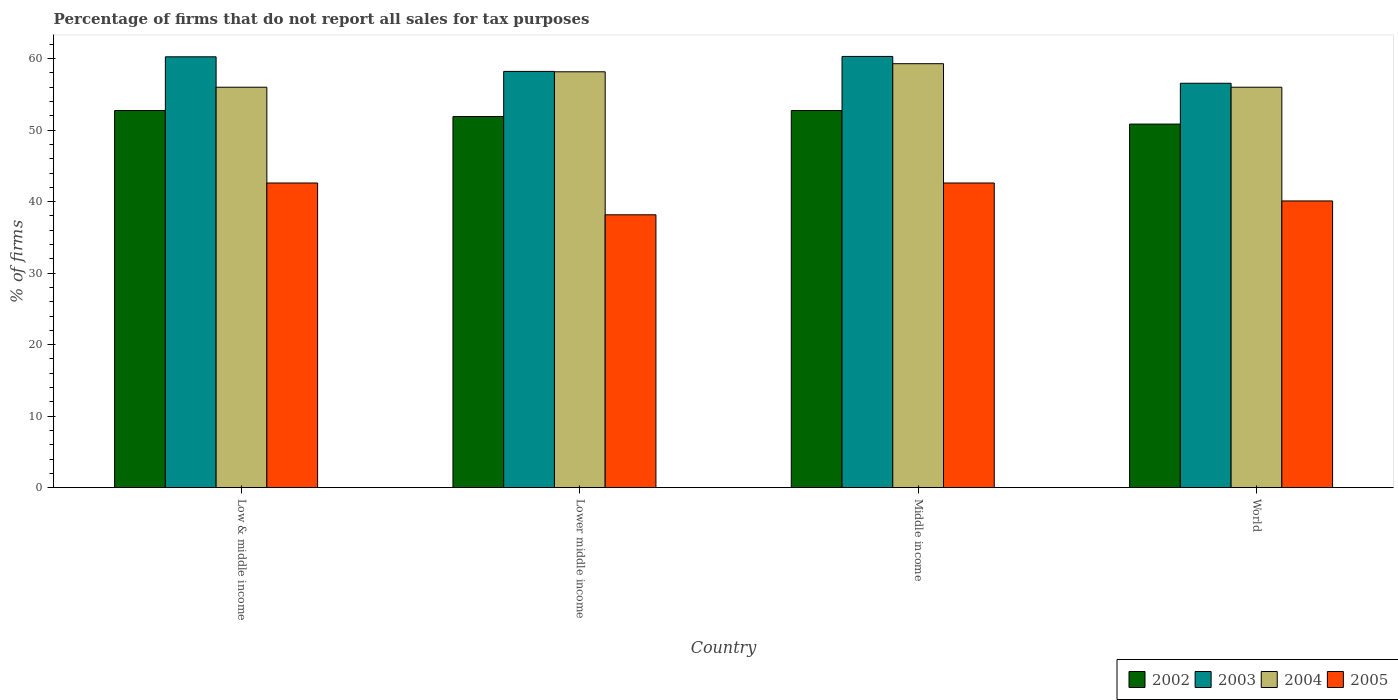How many different coloured bars are there?
Offer a terse response. 4. Are the number of bars per tick equal to the number of legend labels?
Your answer should be compact. Yes. Are the number of bars on each tick of the X-axis equal?
Provide a short and direct response. Yes. How many bars are there on the 4th tick from the left?
Keep it short and to the point. 4. In how many cases, is the number of bars for a given country not equal to the number of legend labels?
Your answer should be very brief. 0. What is the percentage of firms that do not report all sales for tax purposes in 2003 in Middle income?
Provide a short and direct response. 60.31. Across all countries, what is the maximum percentage of firms that do not report all sales for tax purposes in 2004?
Keep it short and to the point. 59.3. Across all countries, what is the minimum percentage of firms that do not report all sales for tax purposes in 2003?
Keep it short and to the point. 56.56. In which country was the percentage of firms that do not report all sales for tax purposes in 2004 minimum?
Make the answer very short. Low & middle income. What is the total percentage of firms that do not report all sales for tax purposes in 2004 in the graph?
Offer a terse response. 229.47. What is the difference between the percentage of firms that do not report all sales for tax purposes in 2005 in Low & middle income and that in Middle income?
Keep it short and to the point. 0. What is the difference between the percentage of firms that do not report all sales for tax purposes in 2004 in World and the percentage of firms that do not report all sales for tax purposes in 2003 in Lower middle income?
Your answer should be very brief. -2.21. What is the average percentage of firms that do not report all sales for tax purposes in 2004 per country?
Offer a terse response. 57.37. What is the difference between the percentage of firms that do not report all sales for tax purposes of/in 2004 and percentage of firms that do not report all sales for tax purposes of/in 2002 in Lower middle income?
Offer a very short reply. 6.26. In how many countries, is the percentage of firms that do not report all sales for tax purposes in 2003 greater than 30 %?
Give a very brief answer. 4. What is the ratio of the percentage of firms that do not report all sales for tax purposes in 2003 in Low & middle income to that in Lower middle income?
Keep it short and to the point. 1.04. What is the difference between the highest and the second highest percentage of firms that do not report all sales for tax purposes in 2005?
Your answer should be very brief. -2.51. What is the difference between the highest and the lowest percentage of firms that do not report all sales for tax purposes in 2003?
Offer a very short reply. 3.75. What does the 1st bar from the left in World represents?
Keep it short and to the point. 2002. What does the 3rd bar from the right in Lower middle income represents?
Offer a terse response. 2003. Is it the case that in every country, the sum of the percentage of firms that do not report all sales for tax purposes in 2004 and percentage of firms that do not report all sales for tax purposes in 2002 is greater than the percentage of firms that do not report all sales for tax purposes in 2003?
Provide a short and direct response. Yes. What is the difference between two consecutive major ticks on the Y-axis?
Offer a very short reply. 10. Does the graph contain any zero values?
Give a very brief answer. No. How many legend labels are there?
Offer a very short reply. 4. What is the title of the graph?
Make the answer very short. Percentage of firms that do not report all sales for tax purposes. What is the label or title of the X-axis?
Your answer should be compact. Country. What is the label or title of the Y-axis?
Keep it short and to the point. % of firms. What is the % of firms of 2002 in Low & middle income?
Your answer should be very brief. 52.75. What is the % of firms of 2003 in Low & middle income?
Your response must be concise. 60.26. What is the % of firms in 2004 in Low & middle income?
Make the answer very short. 56.01. What is the % of firms in 2005 in Low & middle income?
Your answer should be very brief. 42.61. What is the % of firms in 2002 in Lower middle income?
Offer a terse response. 51.91. What is the % of firms of 2003 in Lower middle income?
Ensure brevity in your answer.  58.22. What is the % of firms in 2004 in Lower middle income?
Make the answer very short. 58.16. What is the % of firms in 2005 in Lower middle income?
Keep it short and to the point. 38.16. What is the % of firms of 2002 in Middle income?
Offer a very short reply. 52.75. What is the % of firms of 2003 in Middle income?
Ensure brevity in your answer.  60.31. What is the % of firms of 2004 in Middle income?
Keep it short and to the point. 59.3. What is the % of firms of 2005 in Middle income?
Provide a succinct answer. 42.61. What is the % of firms in 2002 in World?
Ensure brevity in your answer.  50.85. What is the % of firms of 2003 in World?
Your response must be concise. 56.56. What is the % of firms in 2004 in World?
Your answer should be very brief. 56.01. What is the % of firms of 2005 in World?
Your answer should be compact. 40.1. Across all countries, what is the maximum % of firms of 2002?
Your answer should be compact. 52.75. Across all countries, what is the maximum % of firms of 2003?
Provide a succinct answer. 60.31. Across all countries, what is the maximum % of firms in 2004?
Your response must be concise. 59.3. Across all countries, what is the maximum % of firms in 2005?
Offer a terse response. 42.61. Across all countries, what is the minimum % of firms of 2002?
Your answer should be compact. 50.85. Across all countries, what is the minimum % of firms of 2003?
Offer a terse response. 56.56. Across all countries, what is the minimum % of firms of 2004?
Ensure brevity in your answer.  56.01. Across all countries, what is the minimum % of firms in 2005?
Provide a short and direct response. 38.16. What is the total % of firms in 2002 in the graph?
Your answer should be compact. 208.25. What is the total % of firms in 2003 in the graph?
Offer a very short reply. 235.35. What is the total % of firms in 2004 in the graph?
Your answer should be very brief. 229.47. What is the total % of firms of 2005 in the graph?
Offer a very short reply. 163.48. What is the difference between the % of firms of 2002 in Low & middle income and that in Lower middle income?
Keep it short and to the point. 0.84. What is the difference between the % of firms of 2003 in Low & middle income and that in Lower middle income?
Your response must be concise. 2.04. What is the difference between the % of firms of 2004 in Low & middle income and that in Lower middle income?
Keep it short and to the point. -2.16. What is the difference between the % of firms in 2005 in Low & middle income and that in Lower middle income?
Keep it short and to the point. 4.45. What is the difference between the % of firms in 2002 in Low & middle income and that in Middle income?
Your answer should be compact. 0. What is the difference between the % of firms of 2003 in Low & middle income and that in Middle income?
Provide a succinct answer. -0.05. What is the difference between the % of firms of 2004 in Low & middle income and that in Middle income?
Ensure brevity in your answer.  -3.29. What is the difference between the % of firms of 2002 in Low & middle income and that in World?
Offer a very short reply. 1.89. What is the difference between the % of firms of 2003 in Low & middle income and that in World?
Make the answer very short. 3.7. What is the difference between the % of firms of 2004 in Low & middle income and that in World?
Offer a very short reply. 0. What is the difference between the % of firms in 2005 in Low & middle income and that in World?
Your response must be concise. 2.51. What is the difference between the % of firms of 2002 in Lower middle income and that in Middle income?
Your response must be concise. -0.84. What is the difference between the % of firms in 2003 in Lower middle income and that in Middle income?
Your answer should be compact. -2.09. What is the difference between the % of firms of 2004 in Lower middle income and that in Middle income?
Provide a short and direct response. -1.13. What is the difference between the % of firms of 2005 in Lower middle income and that in Middle income?
Your answer should be compact. -4.45. What is the difference between the % of firms in 2002 in Lower middle income and that in World?
Your answer should be compact. 1.06. What is the difference between the % of firms of 2003 in Lower middle income and that in World?
Your response must be concise. 1.66. What is the difference between the % of firms of 2004 in Lower middle income and that in World?
Your answer should be compact. 2.16. What is the difference between the % of firms in 2005 in Lower middle income and that in World?
Provide a succinct answer. -1.94. What is the difference between the % of firms in 2002 in Middle income and that in World?
Your answer should be very brief. 1.89. What is the difference between the % of firms of 2003 in Middle income and that in World?
Make the answer very short. 3.75. What is the difference between the % of firms in 2004 in Middle income and that in World?
Give a very brief answer. 3.29. What is the difference between the % of firms of 2005 in Middle income and that in World?
Ensure brevity in your answer.  2.51. What is the difference between the % of firms of 2002 in Low & middle income and the % of firms of 2003 in Lower middle income?
Keep it short and to the point. -5.47. What is the difference between the % of firms in 2002 in Low & middle income and the % of firms in 2004 in Lower middle income?
Keep it short and to the point. -5.42. What is the difference between the % of firms of 2002 in Low & middle income and the % of firms of 2005 in Lower middle income?
Provide a succinct answer. 14.58. What is the difference between the % of firms in 2003 in Low & middle income and the % of firms in 2004 in Lower middle income?
Offer a terse response. 2.1. What is the difference between the % of firms of 2003 in Low & middle income and the % of firms of 2005 in Lower middle income?
Give a very brief answer. 22.1. What is the difference between the % of firms of 2004 in Low & middle income and the % of firms of 2005 in Lower middle income?
Give a very brief answer. 17.84. What is the difference between the % of firms in 2002 in Low & middle income and the % of firms in 2003 in Middle income?
Your answer should be very brief. -7.57. What is the difference between the % of firms in 2002 in Low & middle income and the % of firms in 2004 in Middle income?
Your answer should be very brief. -6.55. What is the difference between the % of firms of 2002 in Low & middle income and the % of firms of 2005 in Middle income?
Offer a terse response. 10.13. What is the difference between the % of firms in 2003 in Low & middle income and the % of firms in 2004 in Middle income?
Keep it short and to the point. 0.96. What is the difference between the % of firms in 2003 in Low & middle income and the % of firms in 2005 in Middle income?
Keep it short and to the point. 17.65. What is the difference between the % of firms of 2004 in Low & middle income and the % of firms of 2005 in Middle income?
Give a very brief answer. 13.39. What is the difference between the % of firms of 2002 in Low & middle income and the % of firms of 2003 in World?
Ensure brevity in your answer.  -3.81. What is the difference between the % of firms in 2002 in Low & middle income and the % of firms in 2004 in World?
Offer a terse response. -3.26. What is the difference between the % of firms in 2002 in Low & middle income and the % of firms in 2005 in World?
Offer a very short reply. 12.65. What is the difference between the % of firms in 2003 in Low & middle income and the % of firms in 2004 in World?
Your answer should be very brief. 4.25. What is the difference between the % of firms of 2003 in Low & middle income and the % of firms of 2005 in World?
Make the answer very short. 20.16. What is the difference between the % of firms of 2004 in Low & middle income and the % of firms of 2005 in World?
Provide a succinct answer. 15.91. What is the difference between the % of firms in 2002 in Lower middle income and the % of firms in 2003 in Middle income?
Make the answer very short. -8.4. What is the difference between the % of firms in 2002 in Lower middle income and the % of firms in 2004 in Middle income?
Give a very brief answer. -7.39. What is the difference between the % of firms of 2002 in Lower middle income and the % of firms of 2005 in Middle income?
Your response must be concise. 9.3. What is the difference between the % of firms of 2003 in Lower middle income and the % of firms of 2004 in Middle income?
Ensure brevity in your answer.  -1.08. What is the difference between the % of firms of 2003 in Lower middle income and the % of firms of 2005 in Middle income?
Provide a short and direct response. 15.61. What is the difference between the % of firms of 2004 in Lower middle income and the % of firms of 2005 in Middle income?
Your answer should be very brief. 15.55. What is the difference between the % of firms in 2002 in Lower middle income and the % of firms in 2003 in World?
Provide a short and direct response. -4.65. What is the difference between the % of firms of 2002 in Lower middle income and the % of firms of 2004 in World?
Your answer should be compact. -4.1. What is the difference between the % of firms of 2002 in Lower middle income and the % of firms of 2005 in World?
Make the answer very short. 11.81. What is the difference between the % of firms of 2003 in Lower middle income and the % of firms of 2004 in World?
Offer a very short reply. 2.21. What is the difference between the % of firms of 2003 in Lower middle income and the % of firms of 2005 in World?
Your response must be concise. 18.12. What is the difference between the % of firms of 2004 in Lower middle income and the % of firms of 2005 in World?
Make the answer very short. 18.07. What is the difference between the % of firms of 2002 in Middle income and the % of firms of 2003 in World?
Your response must be concise. -3.81. What is the difference between the % of firms of 2002 in Middle income and the % of firms of 2004 in World?
Keep it short and to the point. -3.26. What is the difference between the % of firms of 2002 in Middle income and the % of firms of 2005 in World?
Your response must be concise. 12.65. What is the difference between the % of firms of 2003 in Middle income and the % of firms of 2004 in World?
Provide a short and direct response. 4.31. What is the difference between the % of firms in 2003 in Middle income and the % of firms in 2005 in World?
Provide a succinct answer. 20.21. What is the difference between the % of firms in 2004 in Middle income and the % of firms in 2005 in World?
Ensure brevity in your answer.  19.2. What is the average % of firms of 2002 per country?
Offer a terse response. 52.06. What is the average % of firms in 2003 per country?
Offer a terse response. 58.84. What is the average % of firms of 2004 per country?
Provide a short and direct response. 57.37. What is the average % of firms of 2005 per country?
Your answer should be compact. 40.87. What is the difference between the % of firms in 2002 and % of firms in 2003 in Low & middle income?
Your answer should be very brief. -7.51. What is the difference between the % of firms in 2002 and % of firms in 2004 in Low & middle income?
Give a very brief answer. -3.26. What is the difference between the % of firms in 2002 and % of firms in 2005 in Low & middle income?
Offer a terse response. 10.13. What is the difference between the % of firms of 2003 and % of firms of 2004 in Low & middle income?
Your answer should be very brief. 4.25. What is the difference between the % of firms of 2003 and % of firms of 2005 in Low & middle income?
Keep it short and to the point. 17.65. What is the difference between the % of firms in 2004 and % of firms in 2005 in Low & middle income?
Make the answer very short. 13.39. What is the difference between the % of firms of 2002 and % of firms of 2003 in Lower middle income?
Your response must be concise. -6.31. What is the difference between the % of firms of 2002 and % of firms of 2004 in Lower middle income?
Offer a very short reply. -6.26. What is the difference between the % of firms of 2002 and % of firms of 2005 in Lower middle income?
Offer a very short reply. 13.75. What is the difference between the % of firms of 2003 and % of firms of 2004 in Lower middle income?
Your response must be concise. 0.05. What is the difference between the % of firms in 2003 and % of firms in 2005 in Lower middle income?
Offer a very short reply. 20.06. What is the difference between the % of firms of 2004 and % of firms of 2005 in Lower middle income?
Give a very brief answer. 20. What is the difference between the % of firms of 2002 and % of firms of 2003 in Middle income?
Offer a very short reply. -7.57. What is the difference between the % of firms of 2002 and % of firms of 2004 in Middle income?
Make the answer very short. -6.55. What is the difference between the % of firms of 2002 and % of firms of 2005 in Middle income?
Give a very brief answer. 10.13. What is the difference between the % of firms of 2003 and % of firms of 2004 in Middle income?
Your answer should be compact. 1.02. What is the difference between the % of firms of 2003 and % of firms of 2005 in Middle income?
Your answer should be compact. 17.7. What is the difference between the % of firms in 2004 and % of firms in 2005 in Middle income?
Offer a terse response. 16.69. What is the difference between the % of firms in 2002 and % of firms in 2003 in World?
Offer a very short reply. -5.71. What is the difference between the % of firms of 2002 and % of firms of 2004 in World?
Offer a very short reply. -5.15. What is the difference between the % of firms in 2002 and % of firms in 2005 in World?
Your response must be concise. 10.75. What is the difference between the % of firms of 2003 and % of firms of 2004 in World?
Give a very brief answer. 0.56. What is the difference between the % of firms of 2003 and % of firms of 2005 in World?
Provide a short and direct response. 16.46. What is the difference between the % of firms in 2004 and % of firms in 2005 in World?
Your response must be concise. 15.91. What is the ratio of the % of firms of 2002 in Low & middle income to that in Lower middle income?
Give a very brief answer. 1.02. What is the ratio of the % of firms in 2003 in Low & middle income to that in Lower middle income?
Provide a short and direct response. 1.04. What is the ratio of the % of firms of 2004 in Low & middle income to that in Lower middle income?
Your answer should be compact. 0.96. What is the ratio of the % of firms of 2005 in Low & middle income to that in Lower middle income?
Your answer should be compact. 1.12. What is the ratio of the % of firms in 2003 in Low & middle income to that in Middle income?
Your response must be concise. 1. What is the ratio of the % of firms of 2004 in Low & middle income to that in Middle income?
Provide a succinct answer. 0.94. What is the ratio of the % of firms in 2002 in Low & middle income to that in World?
Provide a succinct answer. 1.04. What is the ratio of the % of firms in 2003 in Low & middle income to that in World?
Give a very brief answer. 1.07. What is the ratio of the % of firms of 2004 in Low & middle income to that in World?
Your answer should be very brief. 1. What is the ratio of the % of firms of 2005 in Low & middle income to that in World?
Offer a very short reply. 1.06. What is the ratio of the % of firms of 2002 in Lower middle income to that in Middle income?
Your response must be concise. 0.98. What is the ratio of the % of firms in 2003 in Lower middle income to that in Middle income?
Provide a short and direct response. 0.97. What is the ratio of the % of firms of 2004 in Lower middle income to that in Middle income?
Your response must be concise. 0.98. What is the ratio of the % of firms in 2005 in Lower middle income to that in Middle income?
Ensure brevity in your answer.  0.9. What is the ratio of the % of firms of 2002 in Lower middle income to that in World?
Give a very brief answer. 1.02. What is the ratio of the % of firms of 2003 in Lower middle income to that in World?
Your answer should be very brief. 1.03. What is the ratio of the % of firms of 2004 in Lower middle income to that in World?
Keep it short and to the point. 1.04. What is the ratio of the % of firms in 2005 in Lower middle income to that in World?
Ensure brevity in your answer.  0.95. What is the ratio of the % of firms of 2002 in Middle income to that in World?
Keep it short and to the point. 1.04. What is the ratio of the % of firms of 2003 in Middle income to that in World?
Keep it short and to the point. 1.07. What is the ratio of the % of firms of 2004 in Middle income to that in World?
Offer a very short reply. 1.06. What is the ratio of the % of firms in 2005 in Middle income to that in World?
Give a very brief answer. 1.06. What is the difference between the highest and the second highest % of firms in 2002?
Your answer should be compact. 0. What is the difference between the highest and the second highest % of firms of 2003?
Keep it short and to the point. 0.05. What is the difference between the highest and the second highest % of firms of 2004?
Offer a terse response. 1.13. What is the difference between the highest and the lowest % of firms in 2002?
Make the answer very short. 1.89. What is the difference between the highest and the lowest % of firms of 2003?
Make the answer very short. 3.75. What is the difference between the highest and the lowest % of firms of 2004?
Keep it short and to the point. 3.29. What is the difference between the highest and the lowest % of firms in 2005?
Your answer should be compact. 4.45. 